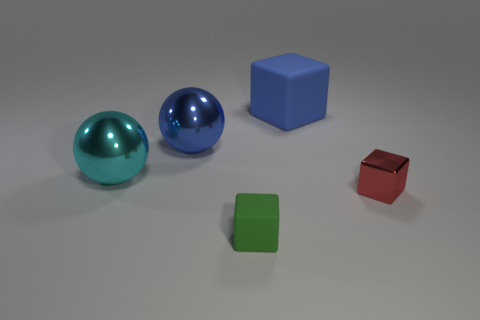Add 2 blue metallic balls. How many objects exist? 7 Subtract all large blue rubber cubes. How many cubes are left? 2 Subtract all cubes. How many objects are left? 2 Subtract all blue balls. How many balls are left? 1 Subtract 0 cyan blocks. How many objects are left? 5 Subtract 1 spheres. How many spheres are left? 1 Subtract all yellow cubes. Subtract all purple spheres. How many cubes are left? 3 Subtract all small green metal things. Subtract all blue objects. How many objects are left? 3 Add 1 matte blocks. How many matte blocks are left? 3 Add 3 big objects. How many big objects exist? 6 